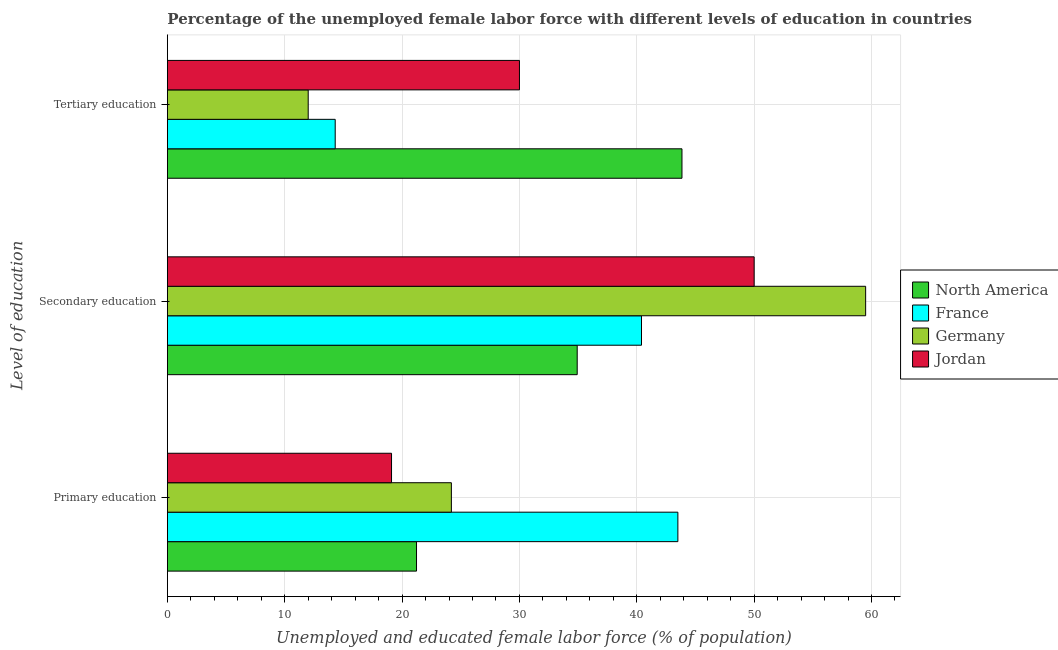How many groups of bars are there?
Your answer should be very brief. 3. Are the number of bars on each tick of the Y-axis equal?
Offer a terse response. Yes. How many bars are there on the 2nd tick from the top?
Offer a very short reply. 4. How many bars are there on the 2nd tick from the bottom?
Offer a terse response. 4. What is the label of the 1st group of bars from the top?
Provide a short and direct response. Tertiary education. What is the percentage of female labor force who received secondary education in France?
Your response must be concise. 40.4. Across all countries, what is the maximum percentage of female labor force who received secondary education?
Provide a succinct answer. 59.5. Across all countries, what is the minimum percentage of female labor force who received tertiary education?
Your response must be concise. 12. In which country was the percentage of female labor force who received tertiary education maximum?
Offer a terse response. North America. What is the total percentage of female labor force who received tertiary education in the graph?
Your answer should be compact. 100.15. What is the difference between the percentage of female labor force who received secondary education in Germany and that in North America?
Your answer should be very brief. 24.58. What is the difference between the percentage of female labor force who received secondary education in North America and the percentage of female labor force who received tertiary education in Jordan?
Your response must be concise. 4.92. What is the average percentage of female labor force who received secondary education per country?
Keep it short and to the point. 46.21. In how many countries, is the percentage of female labor force who received primary education greater than 10 %?
Provide a short and direct response. 4. What is the ratio of the percentage of female labor force who received secondary education in Jordan to that in Germany?
Provide a short and direct response. 0.84. Is the difference between the percentage of female labor force who received primary education in North America and France greater than the difference between the percentage of female labor force who received tertiary education in North America and France?
Offer a very short reply. No. What is the difference between the highest and the second highest percentage of female labor force who received tertiary education?
Give a very brief answer. 13.85. What is the difference between the highest and the lowest percentage of female labor force who received primary education?
Offer a terse response. 24.4. In how many countries, is the percentage of female labor force who received primary education greater than the average percentage of female labor force who received primary education taken over all countries?
Offer a terse response. 1. Is the sum of the percentage of female labor force who received tertiary education in Germany and Jordan greater than the maximum percentage of female labor force who received secondary education across all countries?
Offer a terse response. No. Is it the case that in every country, the sum of the percentage of female labor force who received primary education and percentage of female labor force who received secondary education is greater than the percentage of female labor force who received tertiary education?
Ensure brevity in your answer.  Yes. Are all the bars in the graph horizontal?
Provide a succinct answer. Yes. What is the difference between two consecutive major ticks on the X-axis?
Offer a very short reply. 10. Are the values on the major ticks of X-axis written in scientific E-notation?
Provide a short and direct response. No. Does the graph contain any zero values?
Provide a short and direct response. No. How many legend labels are there?
Provide a succinct answer. 4. How are the legend labels stacked?
Your answer should be compact. Vertical. What is the title of the graph?
Your answer should be very brief. Percentage of the unemployed female labor force with different levels of education in countries. Does "Lithuania" appear as one of the legend labels in the graph?
Your answer should be compact. No. What is the label or title of the X-axis?
Your answer should be very brief. Unemployed and educated female labor force (% of population). What is the label or title of the Y-axis?
Your response must be concise. Level of education. What is the Unemployed and educated female labor force (% of population) in North America in Primary education?
Keep it short and to the point. 21.23. What is the Unemployed and educated female labor force (% of population) of France in Primary education?
Provide a succinct answer. 43.5. What is the Unemployed and educated female labor force (% of population) in Germany in Primary education?
Your response must be concise. 24.2. What is the Unemployed and educated female labor force (% of population) in Jordan in Primary education?
Keep it short and to the point. 19.1. What is the Unemployed and educated female labor force (% of population) of North America in Secondary education?
Your answer should be very brief. 34.92. What is the Unemployed and educated female labor force (% of population) in France in Secondary education?
Offer a very short reply. 40.4. What is the Unemployed and educated female labor force (% of population) of Germany in Secondary education?
Give a very brief answer. 59.5. What is the Unemployed and educated female labor force (% of population) in Jordan in Secondary education?
Ensure brevity in your answer.  50. What is the Unemployed and educated female labor force (% of population) in North America in Tertiary education?
Provide a succinct answer. 43.85. What is the Unemployed and educated female labor force (% of population) of France in Tertiary education?
Provide a succinct answer. 14.3. What is the Unemployed and educated female labor force (% of population) in Jordan in Tertiary education?
Your answer should be compact. 30. Across all Level of education, what is the maximum Unemployed and educated female labor force (% of population) of North America?
Keep it short and to the point. 43.85. Across all Level of education, what is the maximum Unemployed and educated female labor force (% of population) of France?
Provide a short and direct response. 43.5. Across all Level of education, what is the maximum Unemployed and educated female labor force (% of population) in Germany?
Ensure brevity in your answer.  59.5. Across all Level of education, what is the minimum Unemployed and educated female labor force (% of population) in North America?
Make the answer very short. 21.23. Across all Level of education, what is the minimum Unemployed and educated female labor force (% of population) in France?
Your response must be concise. 14.3. Across all Level of education, what is the minimum Unemployed and educated female labor force (% of population) of Jordan?
Give a very brief answer. 19.1. What is the total Unemployed and educated female labor force (% of population) in France in the graph?
Keep it short and to the point. 98.2. What is the total Unemployed and educated female labor force (% of population) in Germany in the graph?
Offer a very short reply. 95.7. What is the total Unemployed and educated female labor force (% of population) of Jordan in the graph?
Your answer should be very brief. 99.1. What is the difference between the Unemployed and educated female labor force (% of population) in North America in Primary education and that in Secondary education?
Offer a very short reply. -13.69. What is the difference between the Unemployed and educated female labor force (% of population) of Germany in Primary education and that in Secondary education?
Keep it short and to the point. -35.3. What is the difference between the Unemployed and educated female labor force (% of population) of Jordan in Primary education and that in Secondary education?
Your response must be concise. -30.9. What is the difference between the Unemployed and educated female labor force (% of population) in North America in Primary education and that in Tertiary education?
Offer a terse response. -22.62. What is the difference between the Unemployed and educated female labor force (% of population) of France in Primary education and that in Tertiary education?
Provide a short and direct response. 29.2. What is the difference between the Unemployed and educated female labor force (% of population) of North America in Secondary education and that in Tertiary education?
Provide a succinct answer. -8.93. What is the difference between the Unemployed and educated female labor force (% of population) of France in Secondary education and that in Tertiary education?
Keep it short and to the point. 26.1. What is the difference between the Unemployed and educated female labor force (% of population) in Germany in Secondary education and that in Tertiary education?
Make the answer very short. 47.5. What is the difference between the Unemployed and educated female labor force (% of population) of Jordan in Secondary education and that in Tertiary education?
Provide a short and direct response. 20. What is the difference between the Unemployed and educated female labor force (% of population) of North America in Primary education and the Unemployed and educated female labor force (% of population) of France in Secondary education?
Offer a terse response. -19.17. What is the difference between the Unemployed and educated female labor force (% of population) in North America in Primary education and the Unemployed and educated female labor force (% of population) in Germany in Secondary education?
Offer a very short reply. -38.27. What is the difference between the Unemployed and educated female labor force (% of population) in North America in Primary education and the Unemployed and educated female labor force (% of population) in Jordan in Secondary education?
Offer a very short reply. -28.77. What is the difference between the Unemployed and educated female labor force (% of population) in France in Primary education and the Unemployed and educated female labor force (% of population) in Jordan in Secondary education?
Your answer should be very brief. -6.5. What is the difference between the Unemployed and educated female labor force (% of population) of Germany in Primary education and the Unemployed and educated female labor force (% of population) of Jordan in Secondary education?
Make the answer very short. -25.8. What is the difference between the Unemployed and educated female labor force (% of population) in North America in Primary education and the Unemployed and educated female labor force (% of population) in France in Tertiary education?
Ensure brevity in your answer.  6.93. What is the difference between the Unemployed and educated female labor force (% of population) in North America in Primary education and the Unemployed and educated female labor force (% of population) in Germany in Tertiary education?
Ensure brevity in your answer.  9.23. What is the difference between the Unemployed and educated female labor force (% of population) of North America in Primary education and the Unemployed and educated female labor force (% of population) of Jordan in Tertiary education?
Offer a terse response. -8.77. What is the difference between the Unemployed and educated female labor force (% of population) of France in Primary education and the Unemployed and educated female labor force (% of population) of Germany in Tertiary education?
Your answer should be compact. 31.5. What is the difference between the Unemployed and educated female labor force (% of population) in France in Primary education and the Unemployed and educated female labor force (% of population) in Jordan in Tertiary education?
Offer a very short reply. 13.5. What is the difference between the Unemployed and educated female labor force (% of population) in Germany in Primary education and the Unemployed and educated female labor force (% of population) in Jordan in Tertiary education?
Offer a very short reply. -5.8. What is the difference between the Unemployed and educated female labor force (% of population) in North America in Secondary education and the Unemployed and educated female labor force (% of population) in France in Tertiary education?
Provide a succinct answer. 20.62. What is the difference between the Unemployed and educated female labor force (% of population) of North America in Secondary education and the Unemployed and educated female labor force (% of population) of Germany in Tertiary education?
Offer a terse response. 22.92. What is the difference between the Unemployed and educated female labor force (% of population) in North America in Secondary education and the Unemployed and educated female labor force (% of population) in Jordan in Tertiary education?
Provide a succinct answer. 4.92. What is the difference between the Unemployed and educated female labor force (% of population) in France in Secondary education and the Unemployed and educated female labor force (% of population) in Germany in Tertiary education?
Your response must be concise. 28.4. What is the difference between the Unemployed and educated female labor force (% of population) of France in Secondary education and the Unemployed and educated female labor force (% of population) of Jordan in Tertiary education?
Make the answer very short. 10.4. What is the difference between the Unemployed and educated female labor force (% of population) in Germany in Secondary education and the Unemployed and educated female labor force (% of population) in Jordan in Tertiary education?
Your answer should be compact. 29.5. What is the average Unemployed and educated female labor force (% of population) of North America per Level of education?
Ensure brevity in your answer.  33.33. What is the average Unemployed and educated female labor force (% of population) of France per Level of education?
Your answer should be compact. 32.73. What is the average Unemployed and educated female labor force (% of population) of Germany per Level of education?
Your response must be concise. 31.9. What is the average Unemployed and educated female labor force (% of population) in Jordan per Level of education?
Provide a short and direct response. 33.03. What is the difference between the Unemployed and educated female labor force (% of population) in North America and Unemployed and educated female labor force (% of population) in France in Primary education?
Provide a succinct answer. -22.27. What is the difference between the Unemployed and educated female labor force (% of population) in North America and Unemployed and educated female labor force (% of population) in Germany in Primary education?
Your response must be concise. -2.97. What is the difference between the Unemployed and educated female labor force (% of population) in North America and Unemployed and educated female labor force (% of population) in Jordan in Primary education?
Provide a succinct answer. 2.13. What is the difference between the Unemployed and educated female labor force (% of population) in France and Unemployed and educated female labor force (% of population) in Germany in Primary education?
Your answer should be very brief. 19.3. What is the difference between the Unemployed and educated female labor force (% of population) in France and Unemployed and educated female labor force (% of population) in Jordan in Primary education?
Offer a terse response. 24.4. What is the difference between the Unemployed and educated female labor force (% of population) in Germany and Unemployed and educated female labor force (% of population) in Jordan in Primary education?
Ensure brevity in your answer.  5.1. What is the difference between the Unemployed and educated female labor force (% of population) of North America and Unemployed and educated female labor force (% of population) of France in Secondary education?
Provide a succinct answer. -5.48. What is the difference between the Unemployed and educated female labor force (% of population) of North America and Unemployed and educated female labor force (% of population) of Germany in Secondary education?
Your answer should be very brief. -24.58. What is the difference between the Unemployed and educated female labor force (% of population) in North America and Unemployed and educated female labor force (% of population) in Jordan in Secondary education?
Offer a terse response. -15.08. What is the difference between the Unemployed and educated female labor force (% of population) in France and Unemployed and educated female labor force (% of population) in Germany in Secondary education?
Make the answer very short. -19.1. What is the difference between the Unemployed and educated female labor force (% of population) in France and Unemployed and educated female labor force (% of population) in Jordan in Secondary education?
Your answer should be very brief. -9.6. What is the difference between the Unemployed and educated female labor force (% of population) in North America and Unemployed and educated female labor force (% of population) in France in Tertiary education?
Ensure brevity in your answer.  29.55. What is the difference between the Unemployed and educated female labor force (% of population) in North America and Unemployed and educated female labor force (% of population) in Germany in Tertiary education?
Offer a very short reply. 31.85. What is the difference between the Unemployed and educated female labor force (% of population) in North America and Unemployed and educated female labor force (% of population) in Jordan in Tertiary education?
Offer a very short reply. 13.85. What is the difference between the Unemployed and educated female labor force (% of population) of France and Unemployed and educated female labor force (% of population) of Jordan in Tertiary education?
Give a very brief answer. -15.7. What is the ratio of the Unemployed and educated female labor force (% of population) of North America in Primary education to that in Secondary education?
Offer a terse response. 0.61. What is the ratio of the Unemployed and educated female labor force (% of population) of France in Primary education to that in Secondary education?
Make the answer very short. 1.08. What is the ratio of the Unemployed and educated female labor force (% of population) of Germany in Primary education to that in Secondary education?
Make the answer very short. 0.41. What is the ratio of the Unemployed and educated female labor force (% of population) of Jordan in Primary education to that in Secondary education?
Offer a terse response. 0.38. What is the ratio of the Unemployed and educated female labor force (% of population) in North America in Primary education to that in Tertiary education?
Your response must be concise. 0.48. What is the ratio of the Unemployed and educated female labor force (% of population) of France in Primary education to that in Tertiary education?
Give a very brief answer. 3.04. What is the ratio of the Unemployed and educated female labor force (% of population) of Germany in Primary education to that in Tertiary education?
Offer a terse response. 2.02. What is the ratio of the Unemployed and educated female labor force (% of population) in Jordan in Primary education to that in Tertiary education?
Your answer should be very brief. 0.64. What is the ratio of the Unemployed and educated female labor force (% of population) of North America in Secondary education to that in Tertiary education?
Offer a very short reply. 0.8. What is the ratio of the Unemployed and educated female labor force (% of population) in France in Secondary education to that in Tertiary education?
Offer a terse response. 2.83. What is the ratio of the Unemployed and educated female labor force (% of population) of Germany in Secondary education to that in Tertiary education?
Provide a short and direct response. 4.96. What is the difference between the highest and the second highest Unemployed and educated female labor force (% of population) in North America?
Your answer should be compact. 8.93. What is the difference between the highest and the second highest Unemployed and educated female labor force (% of population) of Germany?
Keep it short and to the point. 35.3. What is the difference between the highest and the lowest Unemployed and educated female labor force (% of population) of North America?
Provide a short and direct response. 22.62. What is the difference between the highest and the lowest Unemployed and educated female labor force (% of population) in France?
Provide a short and direct response. 29.2. What is the difference between the highest and the lowest Unemployed and educated female labor force (% of population) in Germany?
Your response must be concise. 47.5. What is the difference between the highest and the lowest Unemployed and educated female labor force (% of population) of Jordan?
Your response must be concise. 30.9. 